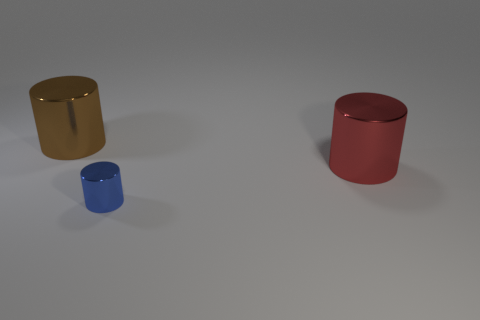The brown thing that is the same material as the big red cylinder is what shape?
Keep it short and to the point. Cylinder. The brown cylinder that is made of the same material as the blue thing is what size?
Offer a terse response. Large. The object that is both left of the red metallic object and right of the brown cylinder has what shape?
Provide a succinct answer. Cylinder. What size is the cylinder behind the big thing in front of the large brown shiny object?
Provide a succinct answer. Large. How many other objects are the same color as the tiny metallic object?
Offer a very short reply. 0. What is the big red cylinder made of?
Keep it short and to the point. Metal. Are there any big metallic objects?
Provide a succinct answer. Yes. Are there an equal number of big metal objects that are left of the big brown cylinder and small rubber blocks?
Your answer should be very brief. Yes. Is there any other thing that has the same material as the large red cylinder?
Provide a short and direct response. Yes. How many large objects are either red cylinders or shiny things?
Your answer should be compact. 2. 